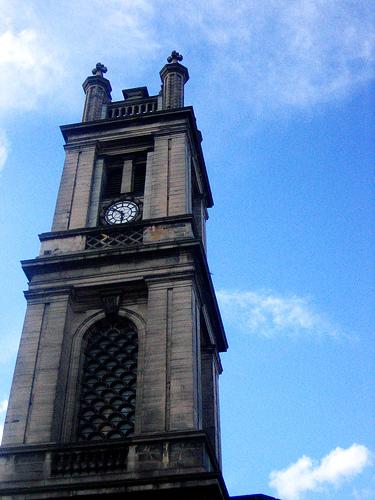How tall is the building?
Write a very short answer. Tall. Does this building have a clock?
Be succinct. Yes. Is this a cloudy day?
Short answer required. No. 